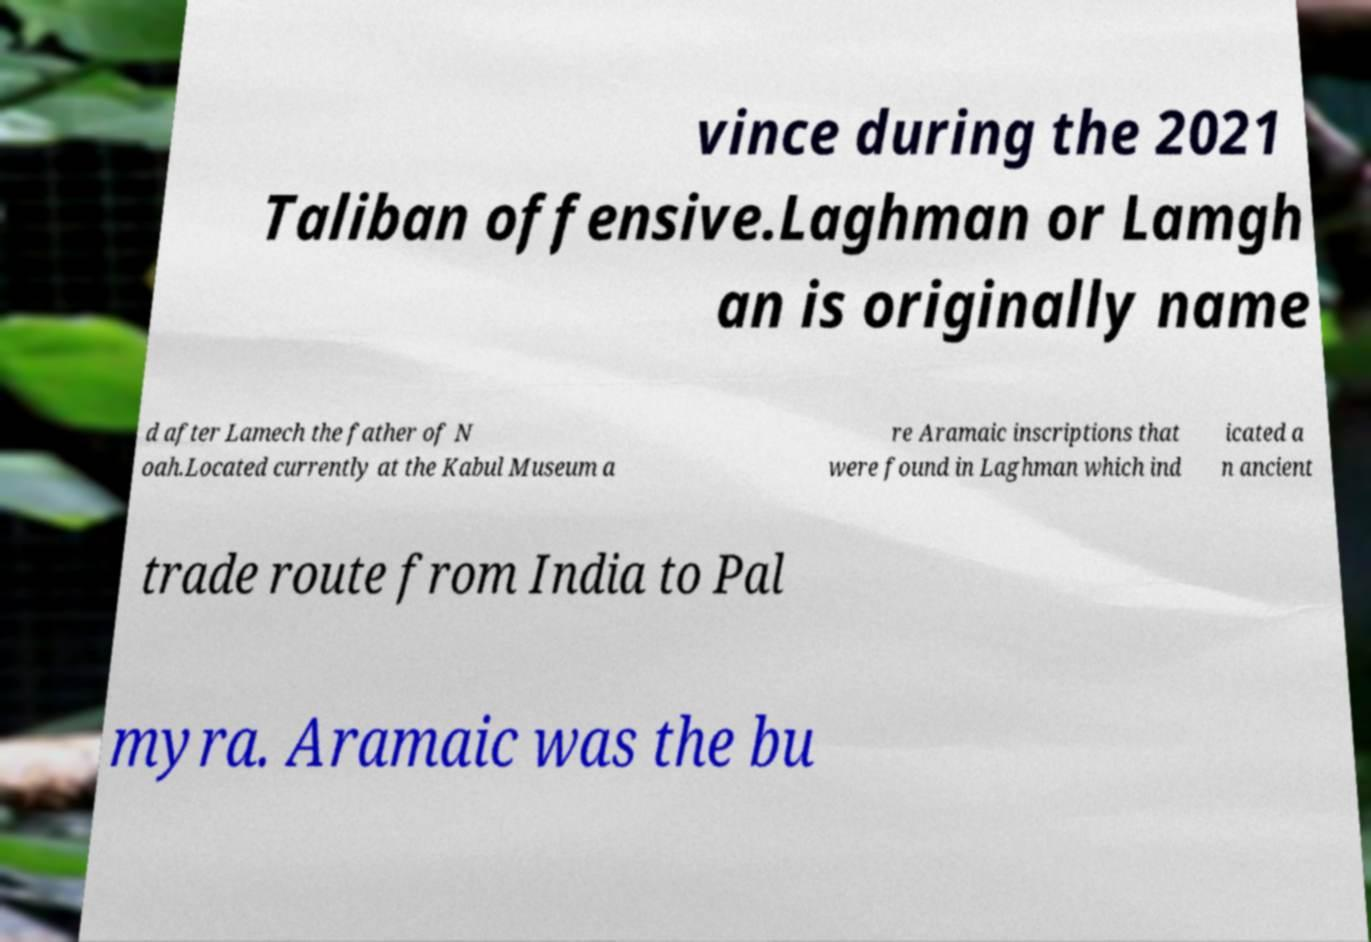I need the written content from this picture converted into text. Can you do that? vince during the 2021 Taliban offensive.Laghman or Lamgh an is originally name d after Lamech the father of N oah.Located currently at the Kabul Museum a re Aramaic inscriptions that were found in Laghman which ind icated a n ancient trade route from India to Pal myra. Aramaic was the bu 